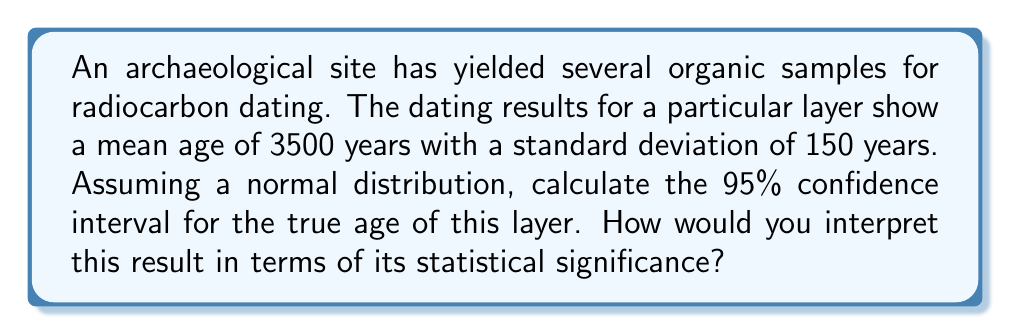Can you solve this math problem? To calculate the 95% confidence interval for the true age of the layer, we need to follow these steps:

1. Identify the given information:
   - Mean age: 3500 years
   - Standard deviation: 150 years
   - Confidence level: 95%

2. For a 95% confidence interval, we use a z-score of 1.96 (from the standard normal distribution table).

3. The formula for the confidence interval is:

   $$ \text{CI} = \bar{x} \pm (z \cdot \frac{s}{\sqrt{n}}) $$

   Where:
   $\bar{x}$ is the sample mean
   $z$ is the z-score for the desired confidence level
   $s$ is the sample standard deviation
   $n$ is the sample size

4. Since we don't have the sample size, we'll use the standard error (SE) directly:

   $$ \text{SE} = \frac{s}{\sqrt{n}} = 150 \text{ years} $$

5. Calculate the margin of error:

   $$ \text{Margin of Error} = z \cdot \text{SE} = 1.96 \cdot 150 = 294 \text{ years} $$

6. Calculate the confidence interval:

   $$ \text{CI} = 3500 \pm 294 \text{ years} $$
   $$ \text{CI} = [3206, 3794] \text{ years} $$

Interpretation:
We can say with 95% confidence that the true age of the layer falls between 3206 and 3794 years. This means that if we were to repeat this sampling process many times, 95% of the calculated intervals would contain the true population parameter (the actual age of the layer).

The statistical significance of this result can be interpreted as follows:
1. Precision: The width of the confidence interval (588 years) relative to the mean age (3500 years) indicates moderate precision. A narrower interval would suggest higher precision.
2. Reliability: The 95% confidence level suggests a high degree of reliability in our estimate.
3. Archaeological implications: This result allows us to place the layer within a specific time period with a known level of certainty, which is crucial for archaeological interpretations and chronology building.

However, as a skeptical archaeology student, you might question:
1. The assumption of normal distribution for radiocarbon dates
2. The potential for contamination or stratigraphic mixing in the samples
3. The calibration of radiocarbon dates and its impact on the confidence interval
4. The appropriateness of using a 95% confidence level in this archaeological context
Answer: The 95% confidence interval for the true age of the layer is [3206, 3794] years. 